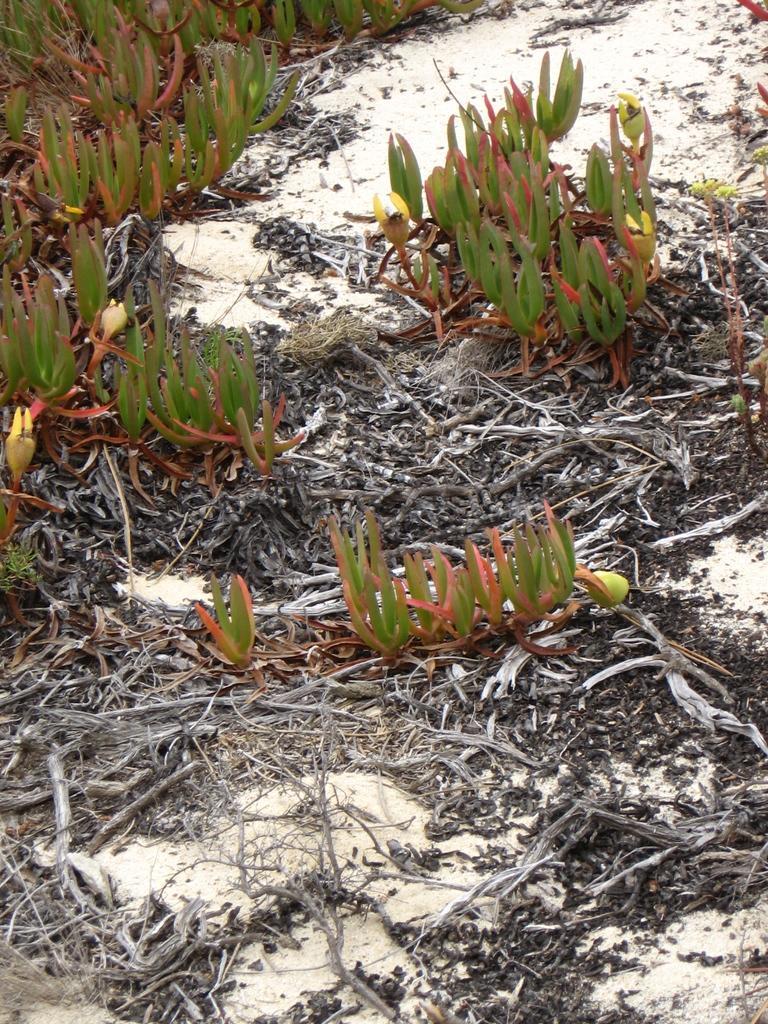Could you give a brief overview of what you see in this image? In this picture we can see dry stems on the land, it seems like plants at the top side. 